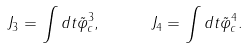<formula> <loc_0><loc_0><loc_500><loc_500>J _ { 3 } = \int d t { \tilde { \varphi } } _ { c } ^ { 3 } , \quad \ J _ { 4 } = \int d t { \tilde { \varphi } } _ { c } ^ { 4 } .</formula> 